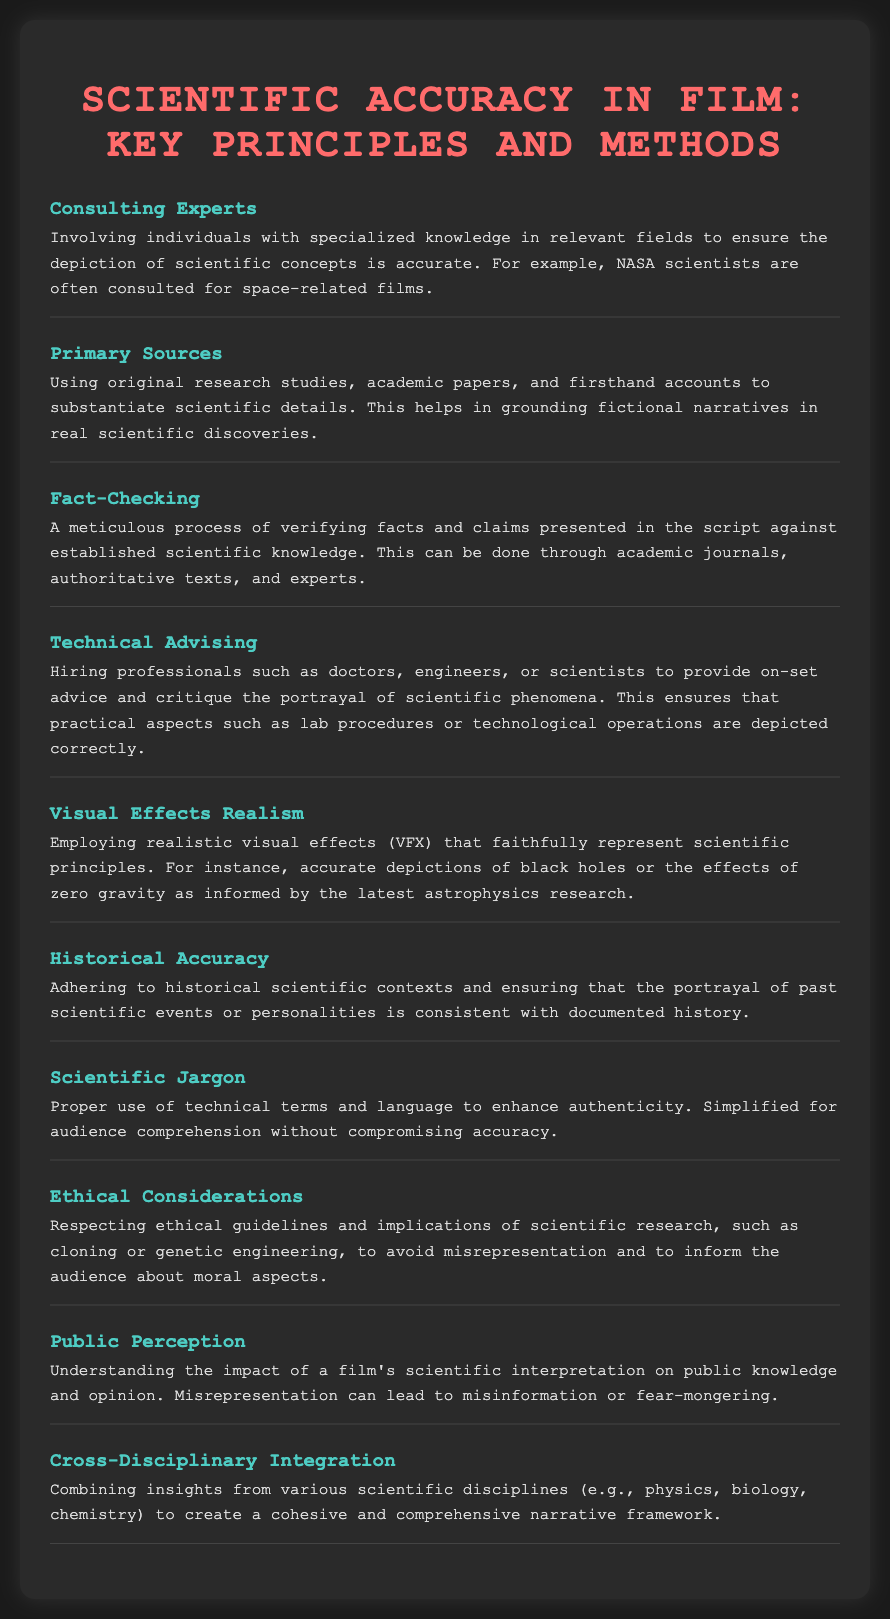What is the role of NASA scientists in films? NASA scientists are often consulted for space-related films to ensure scientific concepts are accurate.
Answer: Consulting Experts What helps ground fictional narratives in real scientific discoveries? Using original research studies, academic papers, and firsthand accounts to substantiate scientific details.
Answer: Primary Sources What process involves verifying facts against established scientific knowledge? A meticulous process of verifying facts and claims presented in the script against established scientific knowledge.
Answer: Fact-Checking Who provides on-set advice for the portrayal of scientific phenomena? Professionals such as doctors, engineers, or scientists are hired to provide on-set advice.
Answer: Technical Advising What is essential for the realistic depiction of scientific principles? Employing realistic visual effects (VFX) that faithfully represent scientific principles.
Answer: Visual Effects Realism What should be adhered to when depicting past scientific events? Ensuring that the portrayal of past scientific events or personalities is consistent with documented history.
Answer: Historical Accuracy What enhances authenticity in a film's scientific language? Proper use of technical terms and language, simplified for audience comprehension without compromising accuracy.
Answer: Scientific Jargon Why is it important to respect ethical guidelines in scientific films? To avoid misrepresentation and to inform the audience about moral aspects.
Answer: Ethical Considerations What can misrepresentation in films lead to? Understanding the impact of a film's scientific interpretation on public knowledge and opinion can prevent misinformation or fear-mongering.
Answer: Public Perception What is combined to create a cohesive narrative framework? Combining insights from various scientific disciplines such as physics, biology, and chemistry.
Answer: Cross-Disciplinary Integration 